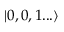Convert formula to latex. <formula><loc_0><loc_0><loc_500><loc_500>| 0 , 0 , 1 \dots \rangle</formula> 